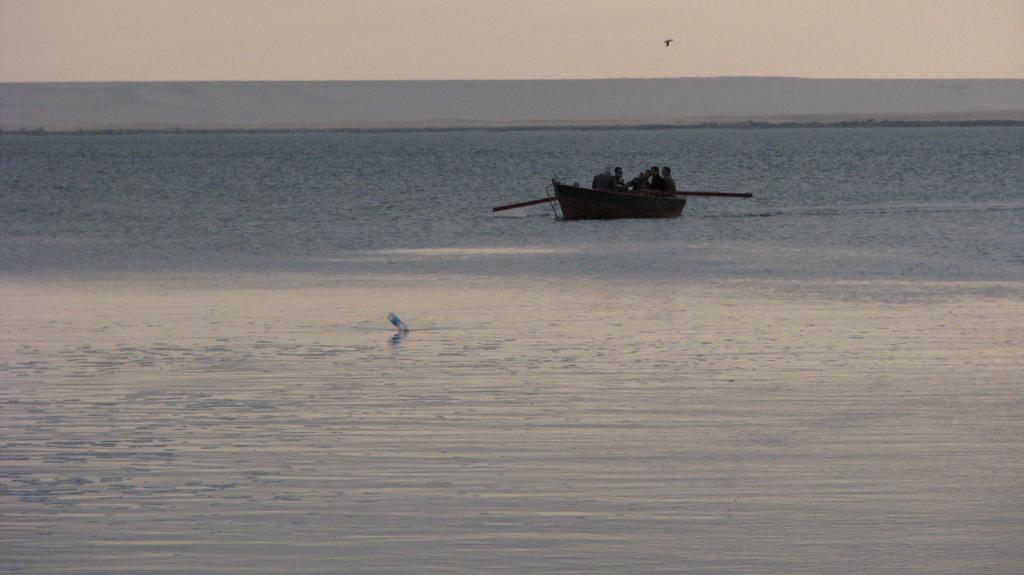Describe this image in one or two sentences. As we can see in the image there is water, few people sitting on boat and there is sky. 